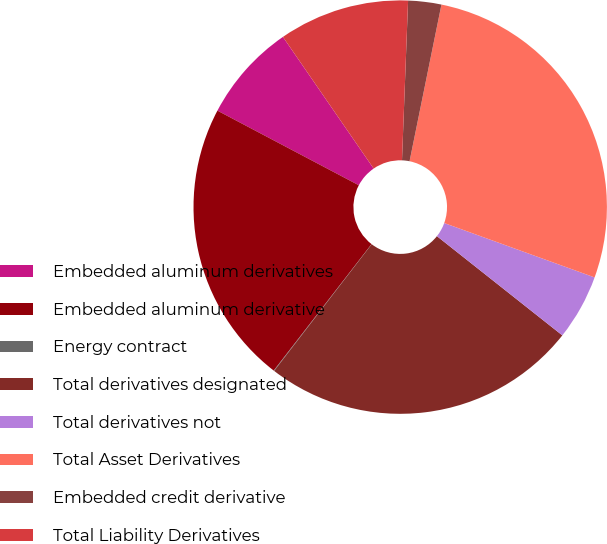Convert chart. <chart><loc_0><loc_0><loc_500><loc_500><pie_chart><fcel>Embedded aluminum derivatives<fcel>Embedded aluminum derivative<fcel>Energy contract<fcel>Total derivatives designated<fcel>Total derivatives not<fcel>Total Asset Derivatives<fcel>Embedded credit derivative<fcel>Total Liability Derivatives<nl><fcel>7.67%<fcel>22.25%<fcel>0.04%<fcel>24.79%<fcel>5.13%<fcel>27.33%<fcel>2.59%<fcel>10.21%<nl></chart> 